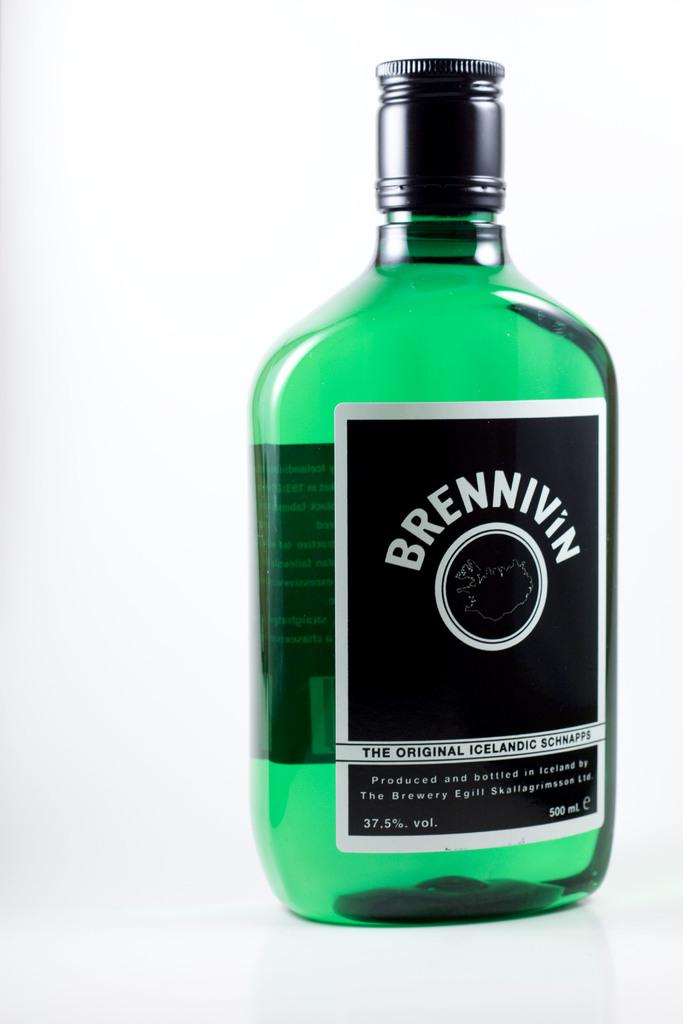<image>
Summarize the visual content of the image. a bottle filled with green liquid called brennivin 